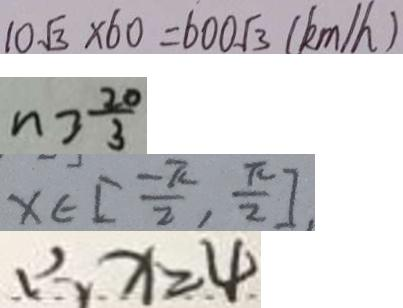<formula> <loc_0><loc_0><loc_500><loc_500>1 0 \sqrt { 3 } \times 6 0 = 6 0 0 \sqrt { 3 } ( k m / h ) 
 n > \frac { 2 0 } { 3 } 
 x \in [ \frac { - \pi } { 2 } , \frac { \pi } { 2 } ] 
 \therefore x = 4</formula> 